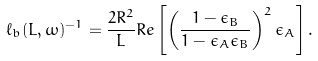<formula> <loc_0><loc_0><loc_500><loc_500>\ell _ { b } ( L , \omega ) ^ { - 1 } = \frac { 2 R ^ { 2 } } { L } R e \left [ \left ( \frac { 1 - \epsilon _ { B } } { 1 - \epsilon _ { A } \epsilon _ { B } } \right ) ^ { 2 } \epsilon _ { A } \right ] .</formula> 